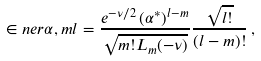<formula> <loc_0><loc_0><loc_500><loc_500>\in n e r { \alpha , m } { l } = \frac { e ^ { - \nu / 2 } \, ( \alpha ^ { * } ) ^ { l - m } } { \sqrt { m ! L _ { m } ( - \nu ) } } \frac { \sqrt { l ! } } { ( l - m ) ! } \, ,</formula> 